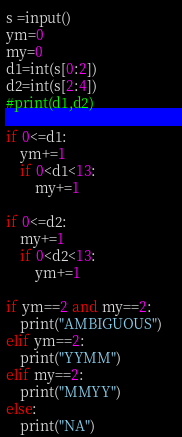<code> <loc_0><loc_0><loc_500><loc_500><_Python_>s =input()
ym=0
my=0
d1=int(s[0:2])
d2=int(s[2:4])
#print(d1,d2)

if 0<=d1:
    ym+=1
    if 0<d1<13:
        my+=1

if 0<=d2:
    my+=1
    if 0<d2<13:
        ym+=1
    
if ym==2 and my==2:
    print("AMBIGUOUS")    
elif ym==2:
    print("YYMM")
elif my==2:
    print("MMYY")
else:
    print("NA")</code> 